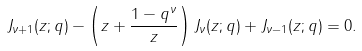<formula> <loc_0><loc_0><loc_500><loc_500>J _ { \nu + 1 } ( z ; q ) - \left ( z + \frac { 1 - q ^ { \nu } } { z } \right ) J _ { \nu } ( z ; q ) + J _ { \nu - 1 } ( z ; q ) = 0 .</formula> 